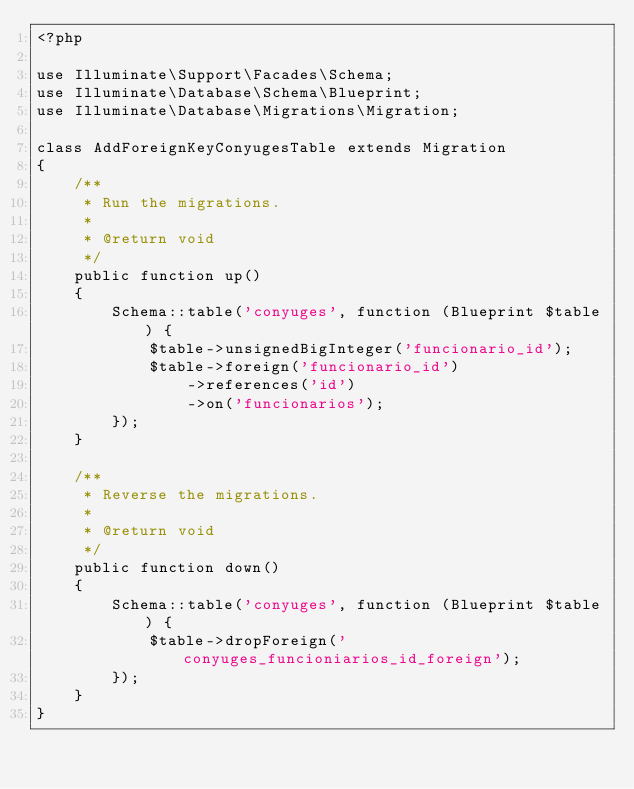<code> <loc_0><loc_0><loc_500><loc_500><_PHP_><?php

use Illuminate\Support\Facades\Schema;
use Illuminate\Database\Schema\Blueprint;
use Illuminate\Database\Migrations\Migration;

class AddForeignKeyConyugesTable extends Migration
{
    /**
     * Run the migrations.
     *
     * @return void
     */
    public function up()
    {
        Schema::table('conyuges', function (Blueprint $table) {
            $table->unsignedBigInteger('funcionario_id');
            $table->foreign('funcionario_id')
                ->references('id')
                ->on('funcionarios');
        });
    }

    /**
     * Reverse the migrations.
     *
     * @return void
     */
    public function down()
    {
        Schema::table('conyuges', function (Blueprint $table) {
            $table->dropForeign('conyuges_funcioniarios_id_foreign');
        });
    }
}
</code> 